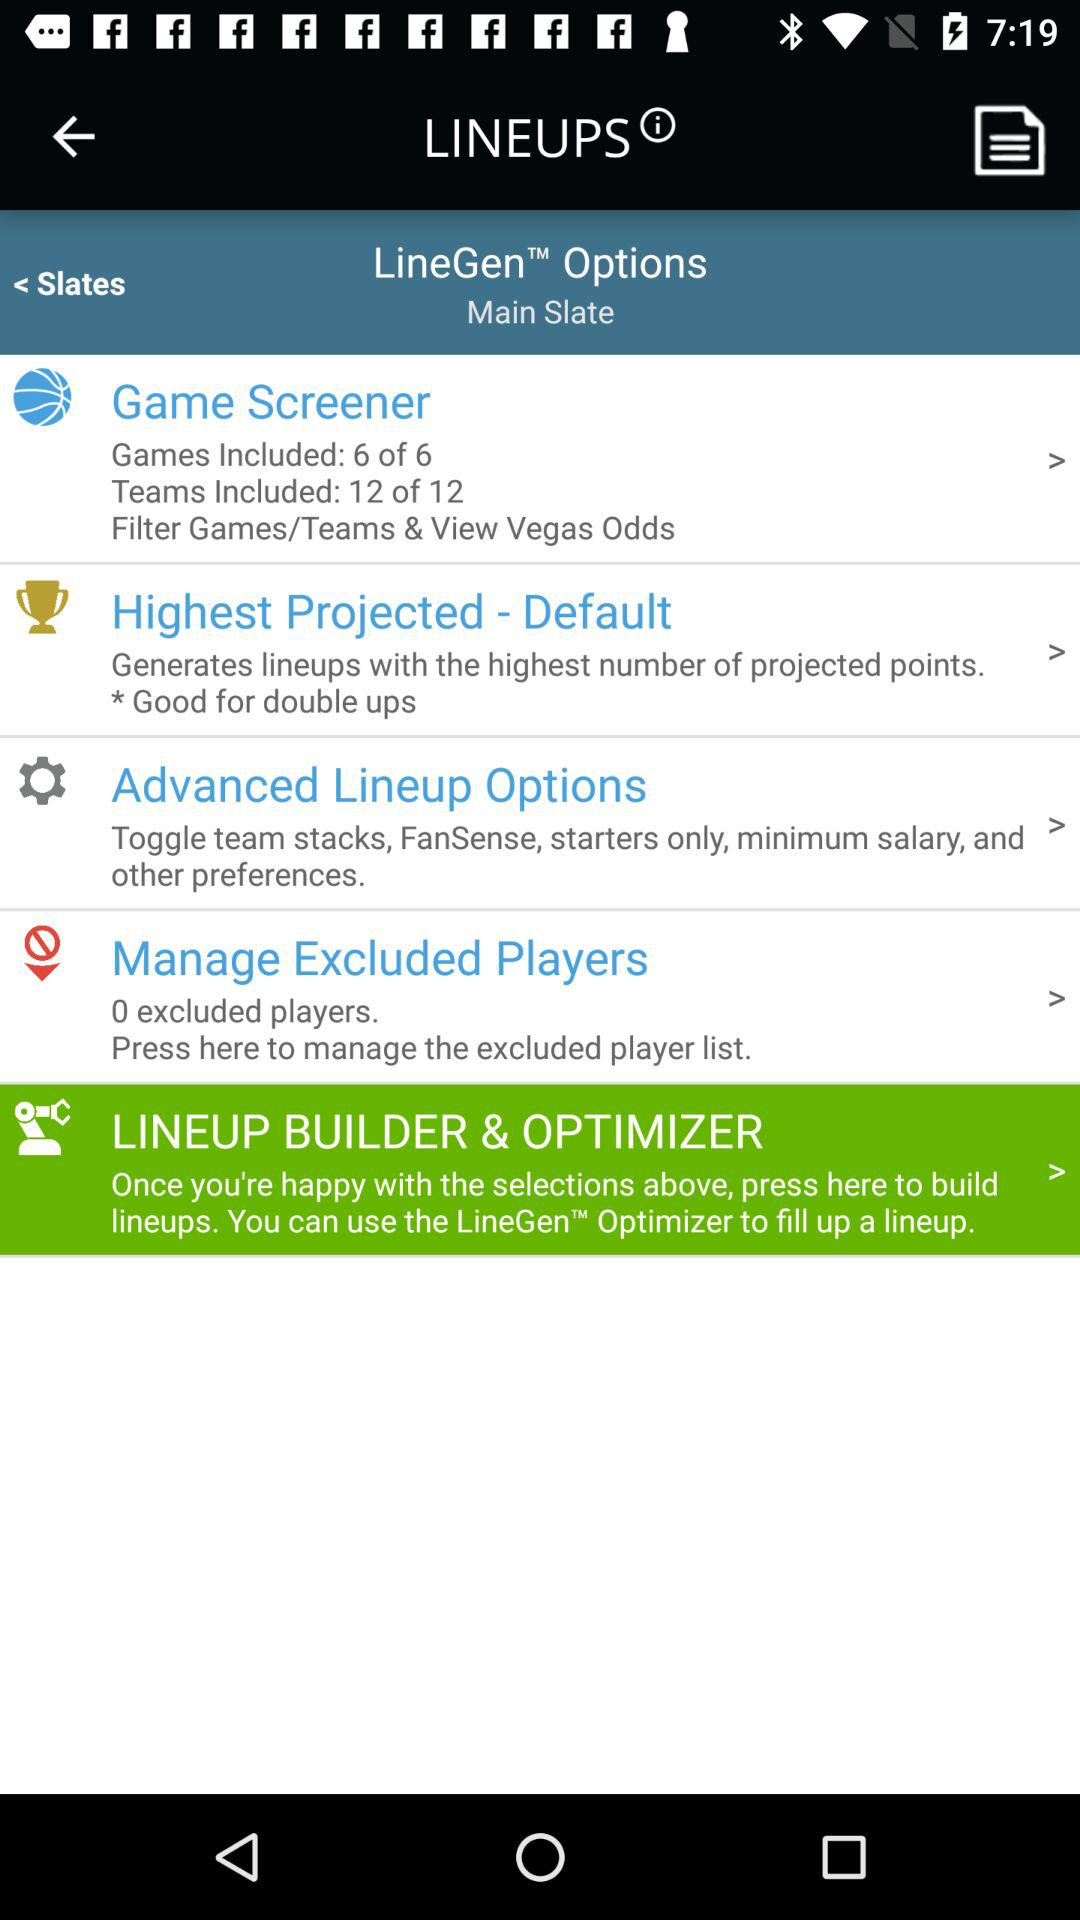What number of teams are included? The number of teams included is 12. 